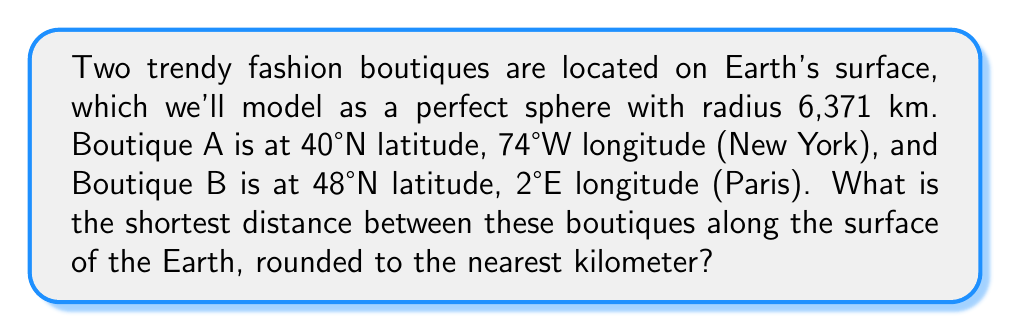Show me your answer to this math problem. To solve this problem, we'll use the great circle distance formula, which gives the shortest path between two points on a sphere. Here's the step-by-step solution:

1. Convert the latitudes and longitudes to radians:
   $\phi_1 = 40° \cdot \frac{\pi}{180} = 0.6981$ rad
   $\lambda_1 = -74° \cdot \frac{\pi}{180} = -1.2915$ rad
   $\phi_2 = 48° \cdot \frac{\pi}{180} = 0.8378$ rad
   $\lambda_2 = 2° \cdot \frac{\pi}{180} = 0.0349$ rad

2. Calculate the central angle $\Delta\sigma$ using the Haversine formula:
   $$\Delta\sigma = 2 \arcsin\left(\sqrt{\sin^2\left(\frac{\phi_2 - \phi_1}{2}\right) + \cos\phi_1 \cos\phi_2 \sin^2\left(\frac{\lambda_2 - \lambda_1}{2}\right)}\right)$$

3. Substitute the values:
   $$\Delta\sigma = 2 \arcsin\left(\sqrt{\sin^2\left(\frac{0.8378 - 0.6981}{2}\right) + \cos(0.6981) \cos(0.8378) \sin^2\left(\frac{0.0349 - (-1.2915)}{2}\right)}\right)$$

4. Calculate:
   $$\Delta\sigma = 2 \arcsin(\sqrt{0.0049 + 0.5838}) = 2 \arcsin(0.7672) = 1.0465\text{ rad}$$

5. The distance $d$ is the arc length, which is the product of the central angle and the Earth's radius:
   $$d = R \cdot \Delta\sigma = 6371 \text{ km} \cdot 1.0465 \text{ rad} = 6667.3 \text{ km}$$

6. Rounding to the nearest kilometer:
   $$d \approx 6667 \text{ km}$$
Answer: 6667 km 